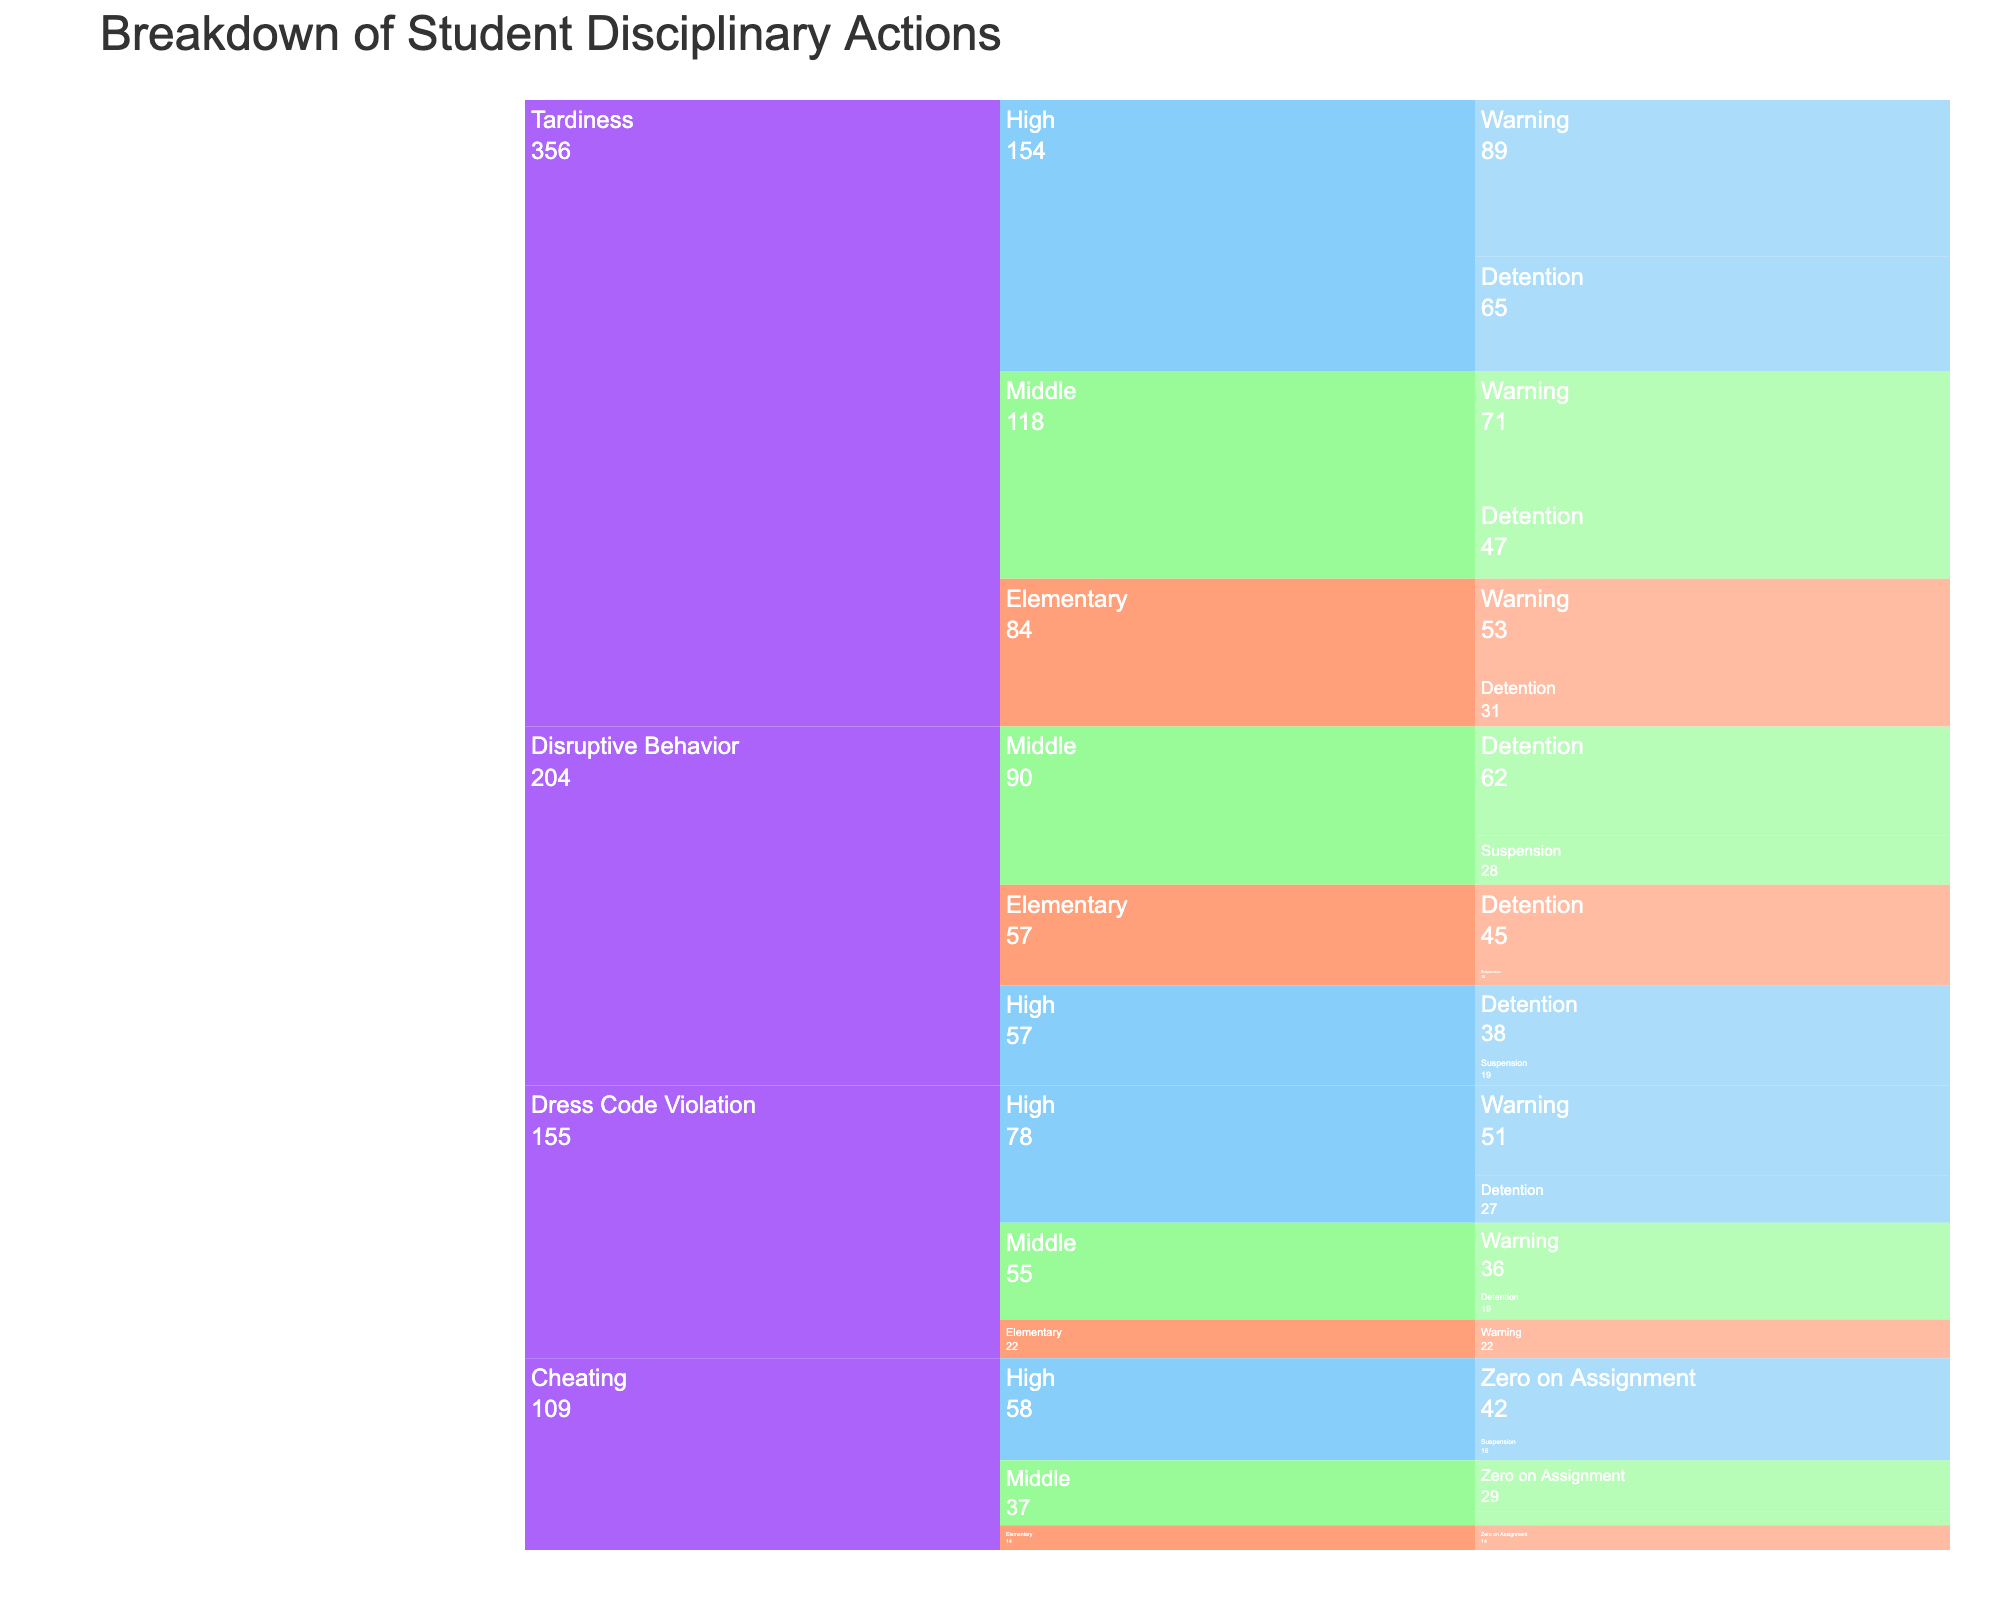what's the most common infraction type? The largest section of the icicle chart, at the root level, represents the most common infraction type. By visual inspection, "Tardiness" is the most common infraction.
Answer: Tardiness Which grade level has the highest number of disciplinary actions for tardiness? Within the "Tardiness" category, the segment with the highest count among the grade levels is visible. High school has the largest segment in the "Tardiness" category.
Answer: High How many students in middle school received a warning for dress code violations? Within the "Dress Code Violation" -> "Middle" path, the size of the "Warning" section represents the count. That section shows 36 students received a warning.
Answer: 36 Compare the number of high school students who received detention for tardiness with those who received detention for disruptive behavior. Which is higher? Look at the "Tardiness" -> "High" -> "Detention" section and "Disruptive Behavior" -> "High" -> "Detention" section. Counts are 65 for tardiness and 38 for disruptive behavior.
Answer: Tardiness What's the total number of students who received suspensions in the middle school category? Add the counts for all infractions leading to suspension within the middle school level. Looking at "Disruptive Behavior" -> "Middle" -> "Suspension" (28) and "Cheating" -> "Middle" -> "Suspension" (8). Total is 28 + 8.
Answer: 36 Which infraction has the smallest count associated with suspensions in high school? Within "High", check the "Suspension" segments under different infractions. Compare the counts under "Disruptive Behavior" (19) and "Cheating" (16).
Answer: Cheating What's the combined count of students who received a zero on an assignment for cheating across all grade levels? Sum the counts under "Cheating" leading to "Zero on Assignment". It includes counts for Elementary (14), Middle (29), and High (42). The total is 14+29+42.
Answer: 85 In which grade level does the dress code violation warning appear most frequently? Compare the sizes of the "Warning" section under "Dress Code Violation" among the grade levels. High school has the largest segment in this category.
Answer: High How many total infractions were recorded for disruptive behavior in elementary school? Sum the counts for all consequences under "Disruptive Behavior" in the elementary school section. Detention (45) and Suspension (12) combined. 45+12.
Answer: 57 